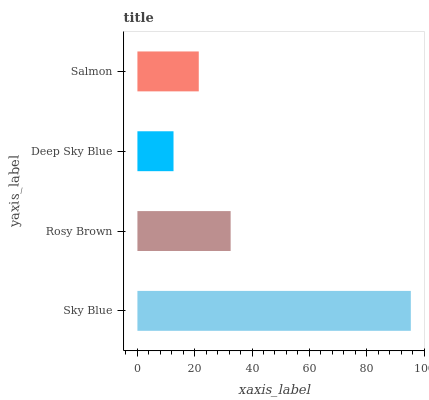Is Deep Sky Blue the minimum?
Answer yes or no. Yes. Is Sky Blue the maximum?
Answer yes or no. Yes. Is Rosy Brown the minimum?
Answer yes or no. No. Is Rosy Brown the maximum?
Answer yes or no. No. Is Sky Blue greater than Rosy Brown?
Answer yes or no. Yes. Is Rosy Brown less than Sky Blue?
Answer yes or no. Yes. Is Rosy Brown greater than Sky Blue?
Answer yes or no. No. Is Sky Blue less than Rosy Brown?
Answer yes or no. No. Is Rosy Brown the high median?
Answer yes or no. Yes. Is Salmon the low median?
Answer yes or no. Yes. Is Deep Sky Blue the high median?
Answer yes or no. No. Is Rosy Brown the low median?
Answer yes or no. No. 